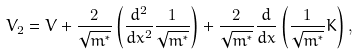<formula> <loc_0><loc_0><loc_500><loc_500>V _ { 2 } = V + \frac { 2 } { \sqrt { m ^ { * } } } \left ( \frac { d ^ { 2 } } { d x ^ { 2 } } \frac { 1 } { \sqrt { m ^ { * } } } \right ) + \frac { 2 } { \sqrt { m ^ { * } } } \frac { d } { d x } \left ( \frac { 1 } { \sqrt { m ^ { * } } } K \right ) ,</formula> 